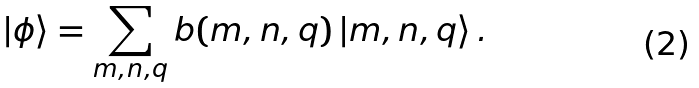<formula> <loc_0><loc_0><loc_500><loc_500>| \phi \rangle = \sum _ { { m } , { n } , { q } } b ( { { m } , { n } , { q } } ) \, | { { m } , { n } , { q } } \rangle \, .</formula> 